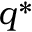<formula> <loc_0><loc_0><loc_500><loc_500>q ^ { * }</formula> 